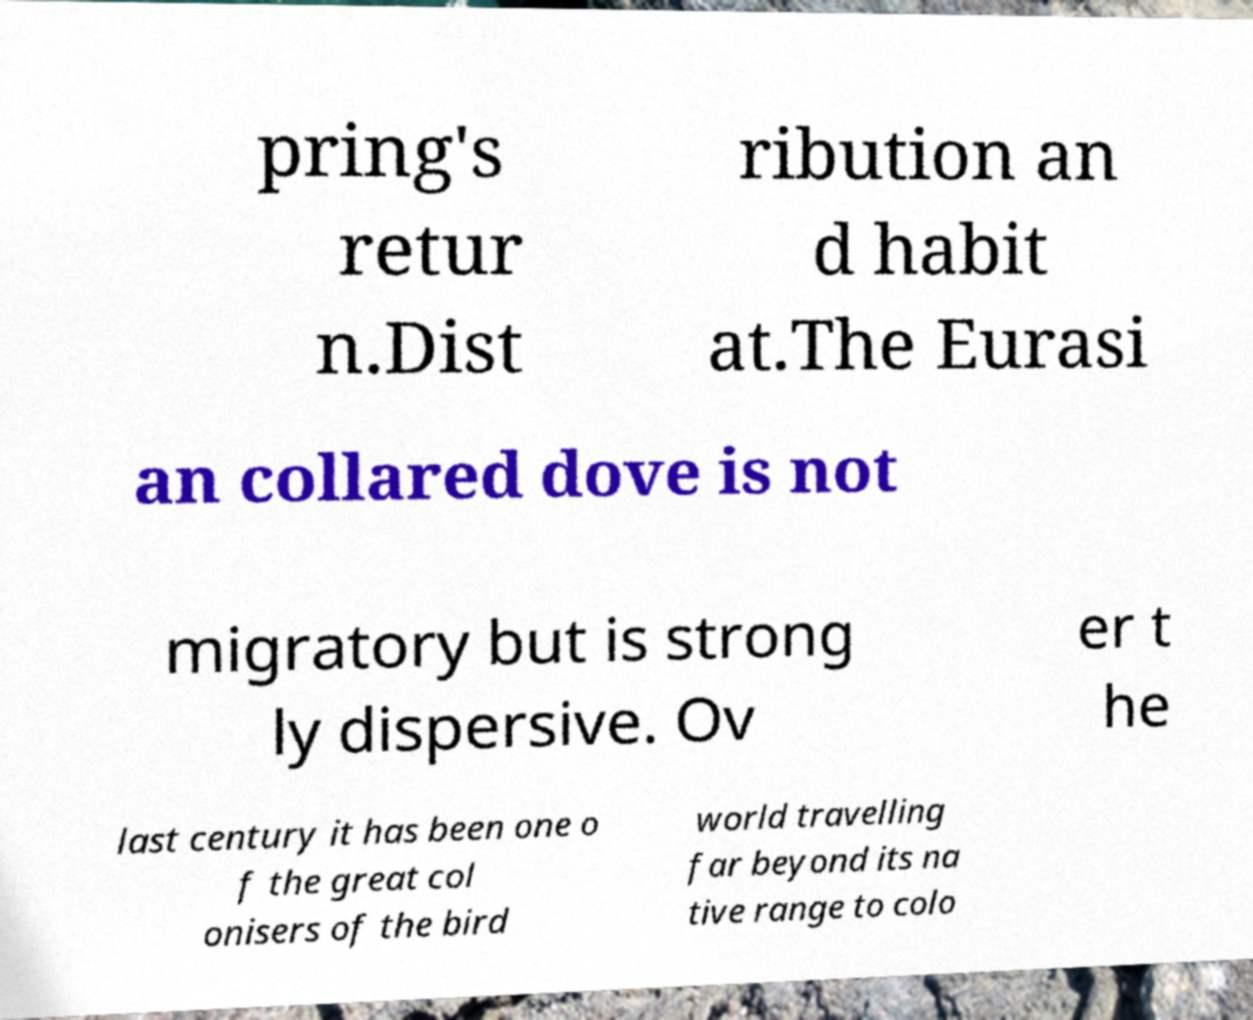Please identify and transcribe the text found in this image. pring's retur n.Dist ribution an d habit at.The Eurasi an collared dove is not migratory but is strong ly dispersive. Ov er t he last century it has been one o f the great col onisers of the bird world travelling far beyond its na tive range to colo 